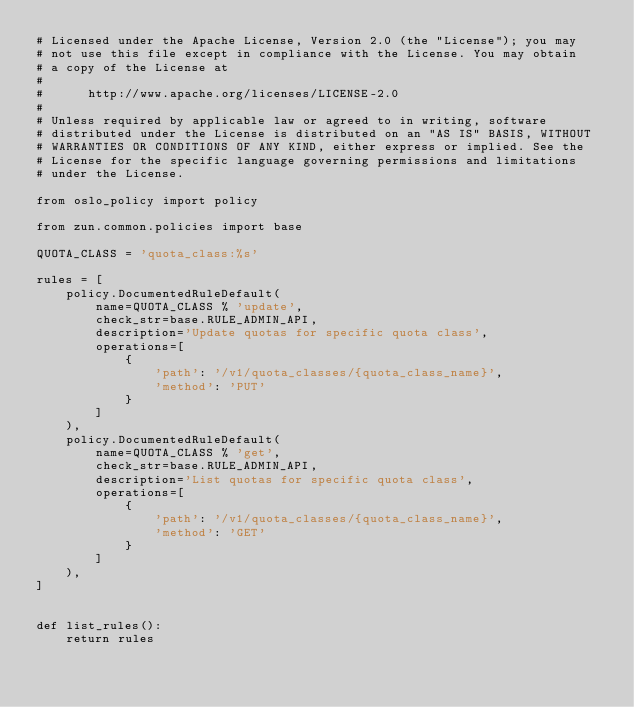<code> <loc_0><loc_0><loc_500><loc_500><_Python_># Licensed under the Apache License, Version 2.0 (the "License"); you may
# not use this file except in compliance with the License. You may obtain
# a copy of the License at
#
#      http://www.apache.org/licenses/LICENSE-2.0
#
# Unless required by applicable law or agreed to in writing, software
# distributed under the License is distributed on an "AS IS" BASIS, WITHOUT
# WARRANTIES OR CONDITIONS OF ANY KIND, either express or implied. See the
# License for the specific language governing permissions and limitations
# under the License.

from oslo_policy import policy

from zun.common.policies import base

QUOTA_CLASS = 'quota_class:%s'

rules = [
    policy.DocumentedRuleDefault(
        name=QUOTA_CLASS % 'update',
        check_str=base.RULE_ADMIN_API,
        description='Update quotas for specific quota class',
        operations=[
            {
                'path': '/v1/quota_classes/{quota_class_name}',
                'method': 'PUT'
            }
        ]
    ),
    policy.DocumentedRuleDefault(
        name=QUOTA_CLASS % 'get',
        check_str=base.RULE_ADMIN_API,
        description='List quotas for specific quota class',
        operations=[
            {
                'path': '/v1/quota_classes/{quota_class_name}',
                'method': 'GET'
            }
        ]
    ),
]


def list_rules():
    return rules
</code> 